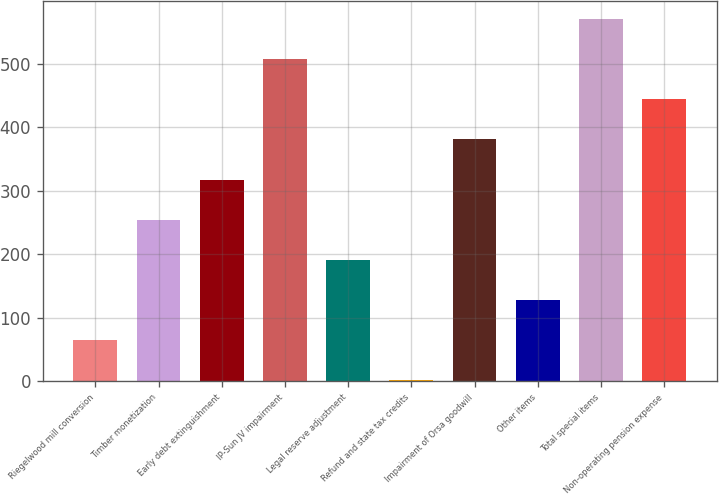Convert chart to OTSL. <chart><loc_0><loc_0><loc_500><loc_500><bar_chart><fcel>Riegelwood mill conversion<fcel>Timber monetization<fcel>Early debt extinguishment<fcel>IP-Sun JV impairment<fcel>Legal reserve adjustment<fcel>Refund and state tax credits<fcel>Impairment of Orsa goodwill<fcel>Other items<fcel>Total special items<fcel>Non-operating pension expense<nl><fcel>65.1<fcel>254.4<fcel>317.5<fcel>506.8<fcel>191.3<fcel>2<fcel>380.6<fcel>128.2<fcel>569.9<fcel>443.7<nl></chart> 